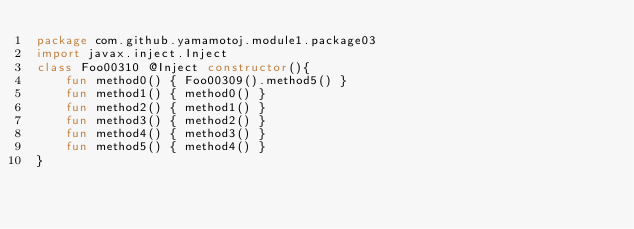<code> <loc_0><loc_0><loc_500><loc_500><_Kotlin_>package com.github.yamamotoj.module1.package03
import javax.inject.Inject
class Foo00310 @Inject constructor(){
    fun method0() { Foo00309().method5() }
    fun method1() { method0() }
    fun method2() { method1() }
    fun method3() { method2() }
    fun method4() { method3() }
    fun method5() { method4() }
}
</code> 